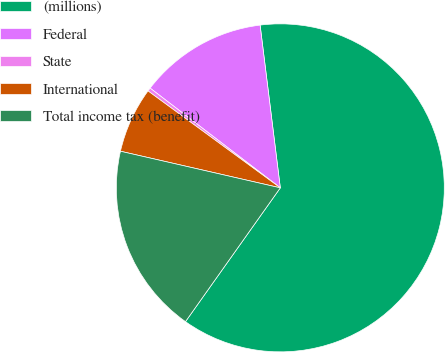Convert chart to OTSL. <chart><loc_0><loc_0><loc_500><loc_500><pie_chart><fcel>(millions)<fcel>Federal<fcel>State<fcel>International<fcel>Total income tax (benefit)<nl><fcel>61.78%<fcel>12.63%<fcel>0.34%<fcel>6.48%<fcel>18.77%<nl></chart> 